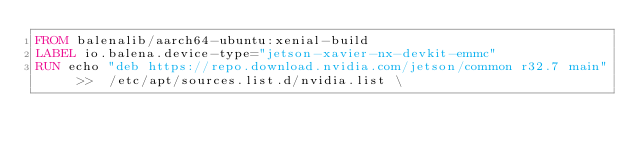Convert code to text. <code><loc_0><loc_0><loc_500><loc_500><_Dockerfile_>FROM balenalib/aarch64-ubuntu:xenial-build
LABEL io.balena.device-type="jetson-xavier-nx-devkit-emmc"
RUN echo "deb https://repo.download.nvidia.com/jetson/common r32.7 main" >>  /etc/apt/sources.list.d/nvidia.list \</code> 